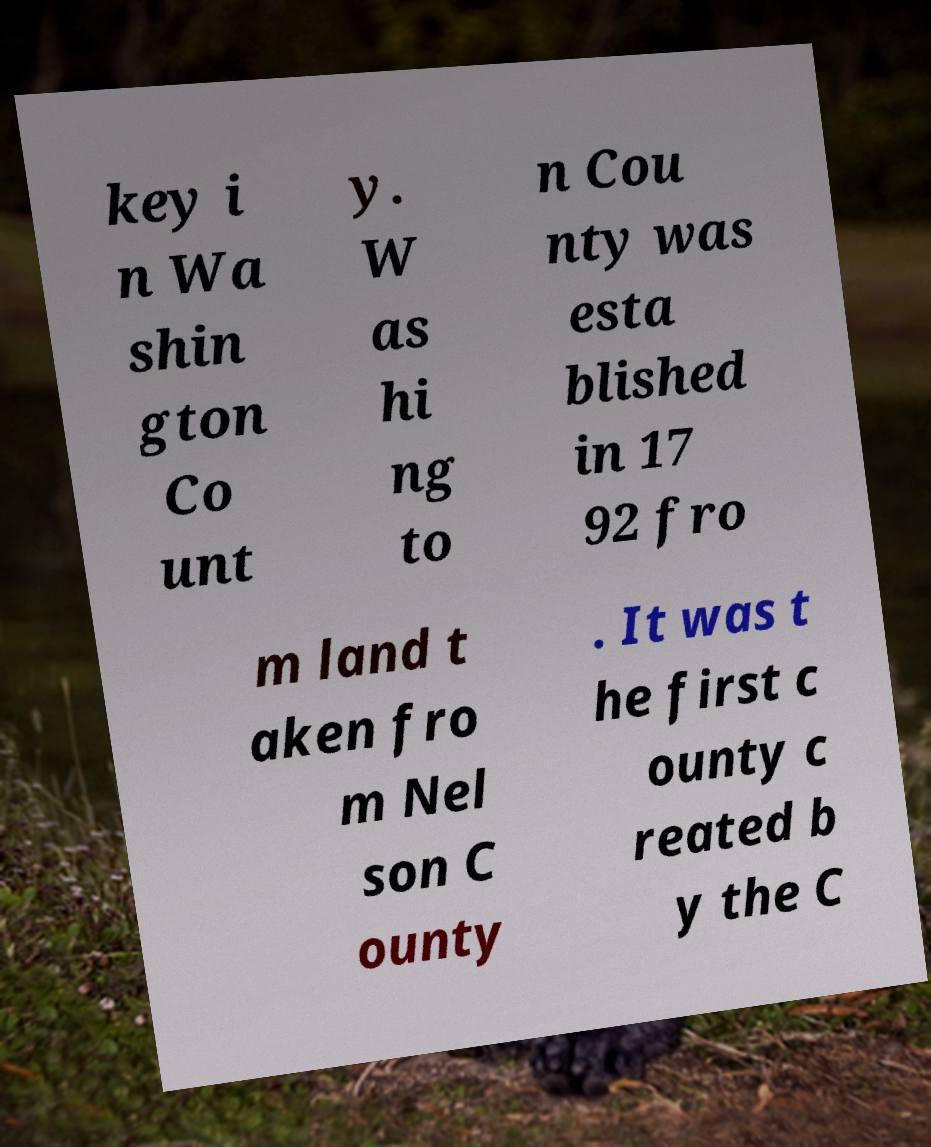For documentation purposes, I need the text within this image transcribed. Could you provide that? key i n Wa shin gton Co unt y. W as hi ng to n Cou nty was esta blished in 17 92 fro m land t aken fro m Nel son C ounty . It was t he first c ounty c reated b y the C 